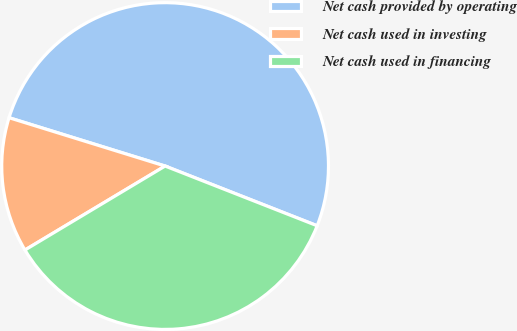Convert chart. <chart><loc_0><loc_0><loc_500><loc_500><pie_chart><fcel>Net cash provided by operating<fcel>Net cash used in investing<fcel>Net cash used in financing<nl><fcel>51.17%<fcel>13.37%<fcel>35.45%<nl></chart> 